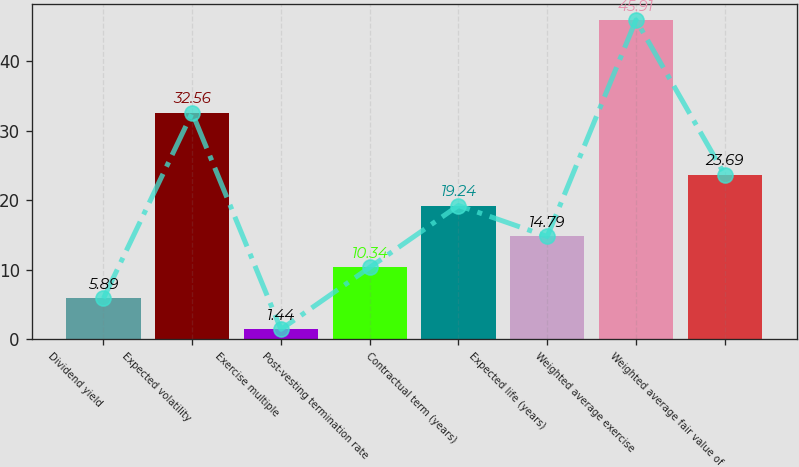Convert chart to OTSL. <chart><loc_0><loc_0><loc_500><loc_500><bar_chart><fcel>Dividend yield<fcel>Expected volatility<fcel>Exercise multiple<fcel>Post-vesting termination rate<fcel>Contractual term (years)<fcel>Expected life (years)<fcel>Weighted average exercise<fcel>Weighted average fair value of<nl><fcel>5.89<fcel>32.56<fcel>1.44<fcel>10.34<fcel>19.24<fcel>14.79<fcel>45.91<fcel>23.69<nl></chart> 